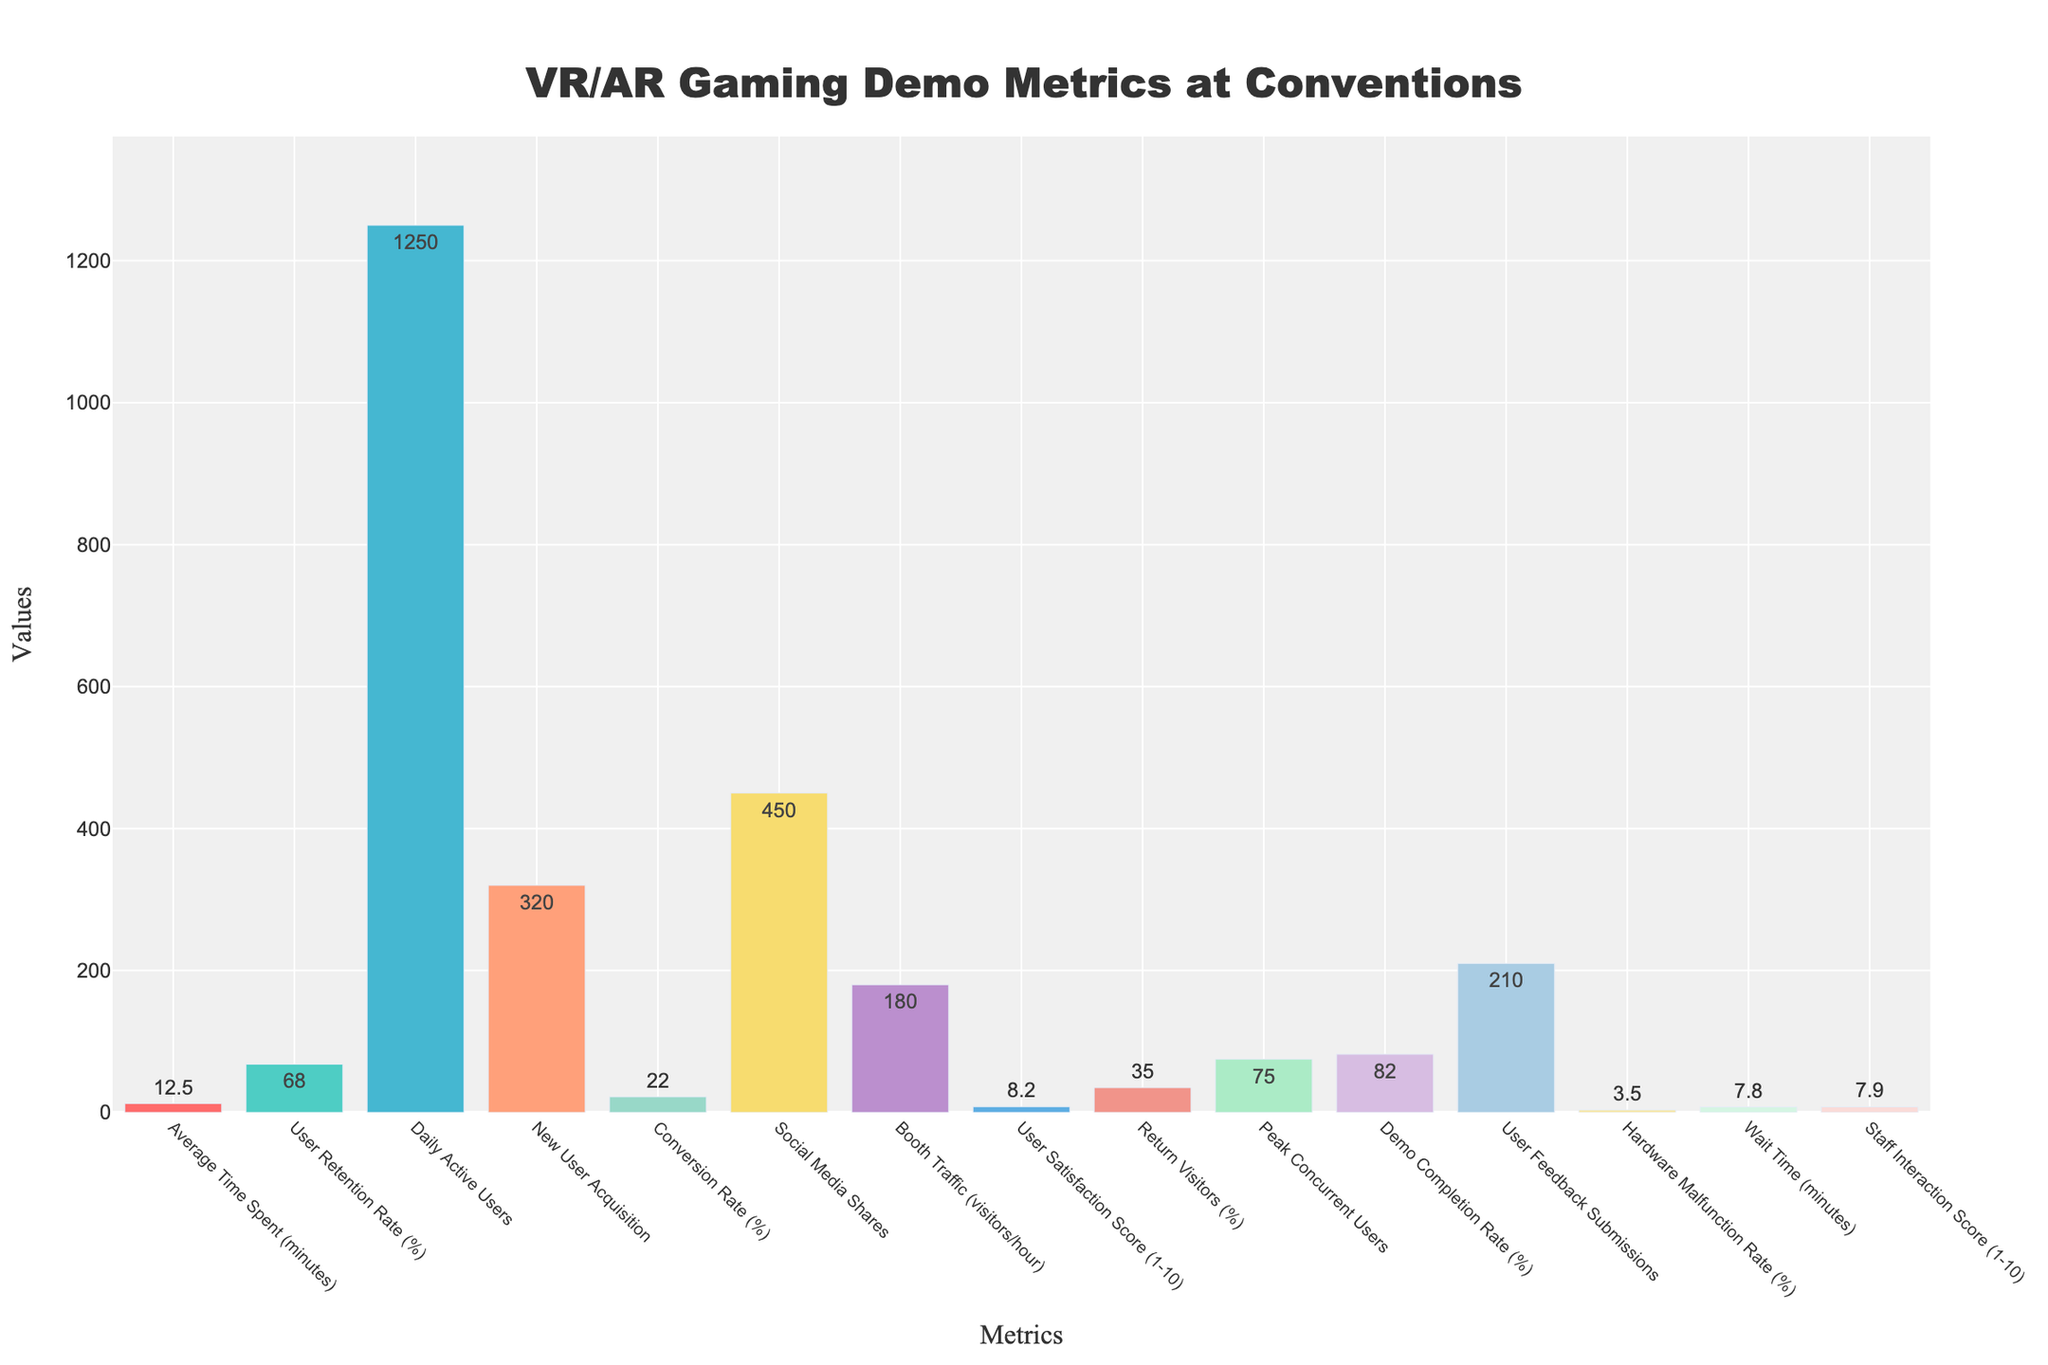What is the highest metric value in the figure? To find the highest metric value, look for the tallest bar. The tallest bar represents "Daily Active Users" with a value of 1250.
Answer: Daily Active Users: 1250 Which metric has the lowest value? Identify the shortest bar in the chart. The shortest bar represents "Hardware Malfunction Rate (%)" with a value of 3.5.
Answer: Hardware Malfunction Rate (%): 3.5 What is the difference between the "User Satisfaction Score" and the "Staff Interaction Score"? Locate the bars for "User Satisfaction Score" and "Staff Interaction Score". The "User Satisfaction Score" is 8.2, and the "Staff Interaction Score" is 7.9. The difference is 8.2 - 7.9.
Answer: 0.3 Among "New User Acquisition" and "Return Visitors (%)", which one is higher? By how much? Find the bars for "New User Acquisition" and "Return Visitors (%)". "New User Acquisition" is 320, and "Return Visitors (%)" is 35. So, 320 - 35 gives the difference.
Answer: New User Acquisition is higher by 285 Which metric has a value between 5 and 10? Scan the bars for values between 5 and 10. "Hardware Malfunction Rate (%)" with a value of 3.5 and "Wait Time (minutes)" with a value of 7.8 fit within this range.
Answer: Wait Time (minutes): 7.8 How do the values of "Average Time Spent (minutes)" and "Peak Concurrent Users" compare? Locate the bars for "Average Time Spent (minutes)" and "Peak Concurrent Users". "Average Time Spent (minutes)" is 12.5, and "Peak Concurrent Users" is 75. Therefore, "Peak Concurrent Users" is higher.
Answer: Peak Concurrent Users is higher What is the sum of "Conversion Rate (%)" and "Demo Completion Rate (%)"? Add the values represented by the bars for "Conversion Rate (%)" and "Demo Completion Rate (%)". The values are 22 and 82, respectively. Thus, 22 + 82 equals 104.
Answer: 104 Which metric is represented by a green-colored bar, and what is its value? Identify the bar colored green. The green bar corresponds to "User Retention Rate (%)" with a value of 68.
Answer: User Retention Rate (%): 68 What is the average value of "New User Acquisition", "Social Media Shares", and "User Feedback Submissions"? Add the values for these metrics and then divide by the number of metrics. "New User Acquisition" is 320, "Social Media Shares" is 450, and "User Feedback Submissions" is 210. Sum (320 + 450 + 210) = 980. Averaging 980 / 3 gives approximately 326.7.
Answer: 326.7 If you combine the metrics "Booth Traffic (visitors/hour)" and "Peak Concurrent Users", what is the total? Sum the values for these metrics. "Booth Traffic (visitors/hour)" is 180, and "Peak Concurrent Users" is 75. Therefore, 180 + 75 equals 255.
Answer: 255 